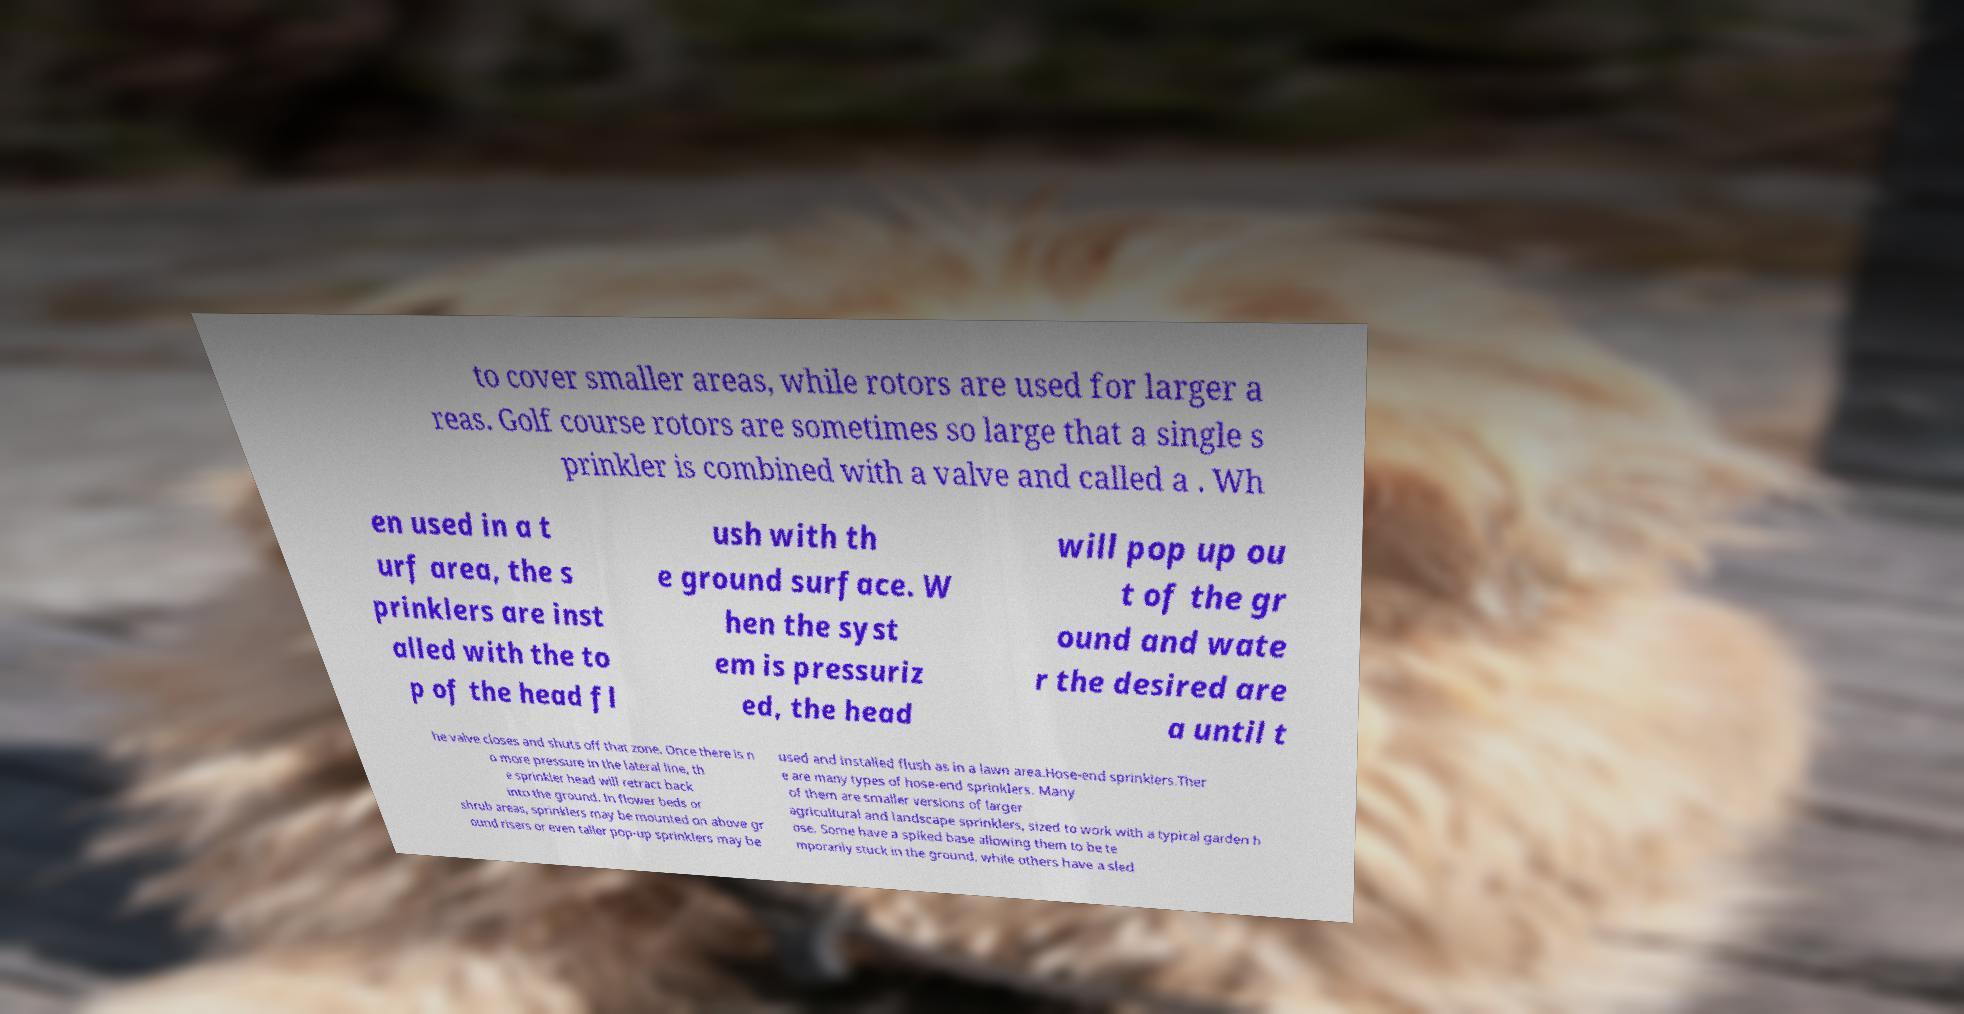Please read and relay the text visible in this image. What does it say? to cover smaller areas, while rotors are used for larger a reas. Golf course rotors are sometimes so large that a single s prinkler is combined with a valve and called a . Wh en used in a t urf area, the s prinklers are inst alled with the to p of the head fl ush with th e ground surface. W hen the syst em is pressuriz ed, the head will pop up ou t of the gr ound and wate r the desired are a until t he valve closes and shuts off that zone. Once there is n o more pressure in the lateral line, th e sprinkler head will retract back into the ground. In flower beds or shrub areas, sprinklers may be mounted on above gr ound risers or even taller pop-up sprinklers may be used and installed flush as in a lawn area.Hose-end sprinklers.Ther e are many types of hose-end sprinklers. Many of them are smaller versions of larger agricultural and landscape sprinklers, sized to work with a typical garden h ose. Some have a spiked base allowing them to be te mporarily stuck in the ground, while others have a sled 